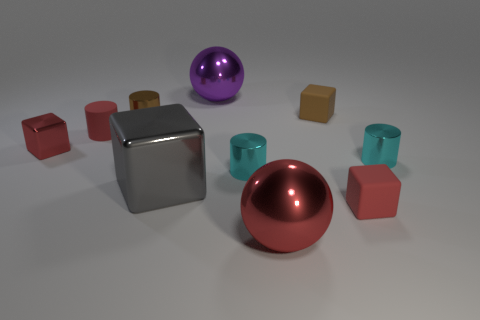How many cyan cylinders must be subtracted to get 1 cyan cylinders? 1 Subtract all brown cylinders. How many cylinders are left? 3 Subtract all cyan cylinders. How many cylinders are left? 2 Subtract all cubes. How many objects are left? 6 Subtract 3 blocks. How many blocks are left? 1 Subtract 0 blue balls. How many objects are left? 10 Subtract all yellow cubes. Subtract all yellow cylinders. How many cubes are left? 4 Subtract all brown spheres. How many red blocks are left? 2 Subtract all tiny rubber cylinders. Subtract all red metallic spheres. How many objects are left? 8 Add 1 big purple objects. How many big purple objects are left? 2 